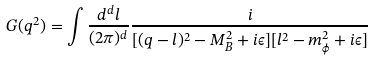Convert formula to latex. <formula><loc_0><loc_0><loc_500><loc_500>G ( q ^ { 2 } ) = \int \frac { d ^ { d } l } { ( 2 \pi ) ^ { d } } \frac { i } { [ ( q - l ) ^ { 2 } - M _ { B } ^ { 2 } + i \epsilon ] [ l ^ { 2 } - m _ { \phi } ^ { 2 } + i \epsilon ] }</formula> 